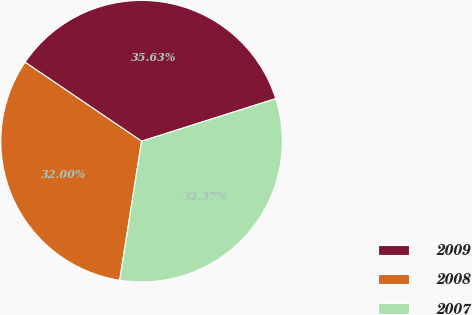Convert chart to OTSL. <chart><loc_0><loc_0><loc_500><loc_500><pie_chart><fcel>2009<fcel>2008<fcel>2007<nl><fcel>35.63%<fcel>32.0%<fcel>32.37%<nl></chart> 